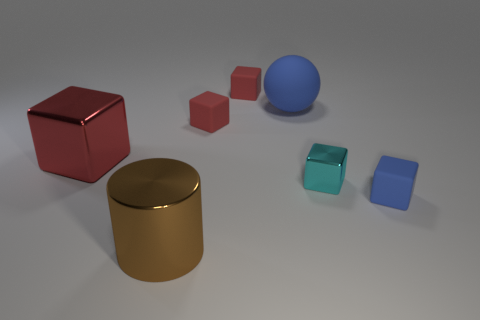Is the size of the object that is behind the blue ball the same as the metallic cube that is on the left side of the big ball?
Your answer should be compact. No. There is a red metal cube; does it have the same size as the blue object to the right of the large blue matte thing?
Provide a short and direct response. No. Are there any rubber cubes right of the small object that is behind the big sphere?
Your answer should be very brief. Yes. Are there fewer large red things than tiny red rubber cubes?
Give a very brief answer. Yes. There is a blue object that is behind the small cube that is in front of the tiny cyan metal object; what is it made of?
Provide a short and direct response. Rubber. Is the size of the blue rubber sphere the same as the blue cube?
Your answer should be compact. No. What number of objects are large purple matte blocks or large red blocks?
Make the answer very short. 1. There is a object that is right of the large rubber sphere and behind the blue cube; how big is it?
Make the answer very short. Small. Is the number of large metal blocks that are left of the large red shiny object less than the number of tiny cyan matte spheres?
Ensure brevity in your answer.  No. The red thing that is the same material as the small cyan object is what shape?
Provide a short and direct response. Cube. 